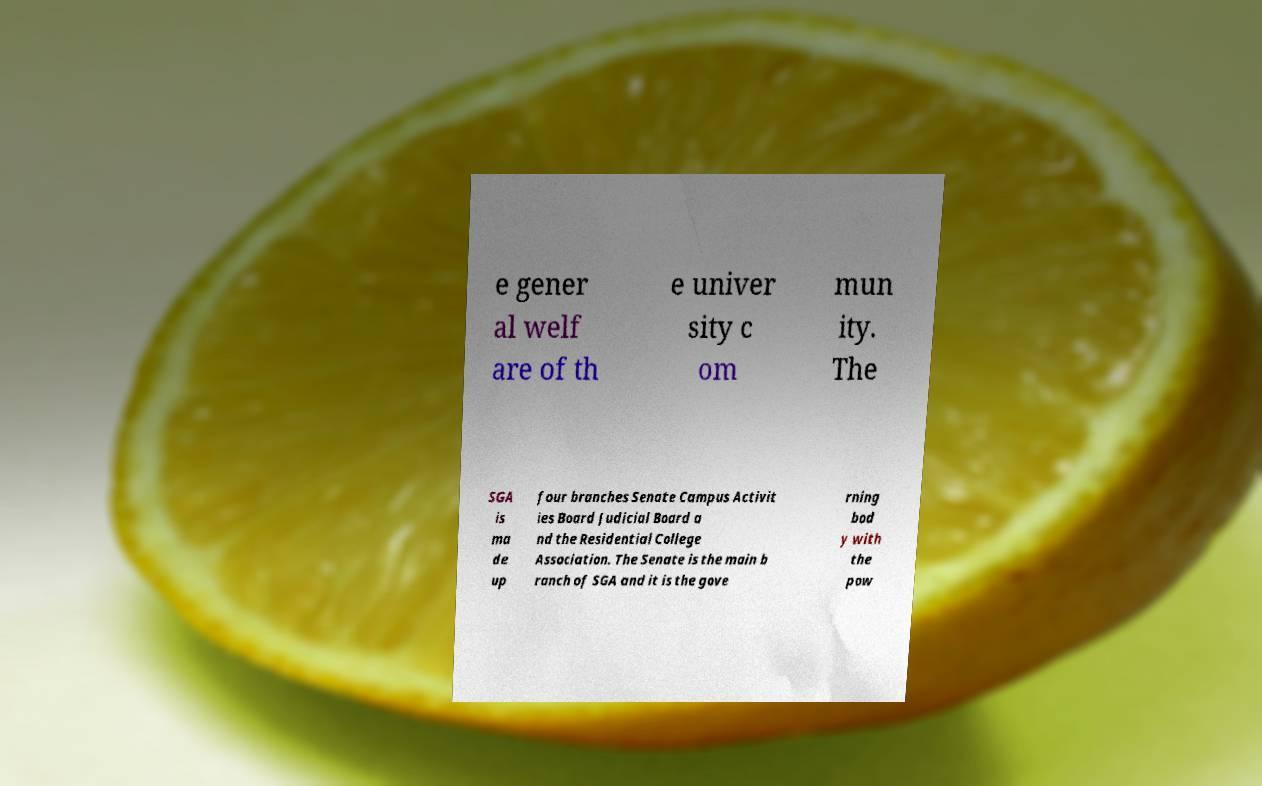Please identify and transcribe the text found in this image. e gener al welf are of th e univer sity c om mun ity. The SGA is ma de up four branches Senate Campus Activit ies Board Judicial Board a nd the Residential College Association. The Senate is the main b ranch of SGA and it is the gove rning bod y with the pow 